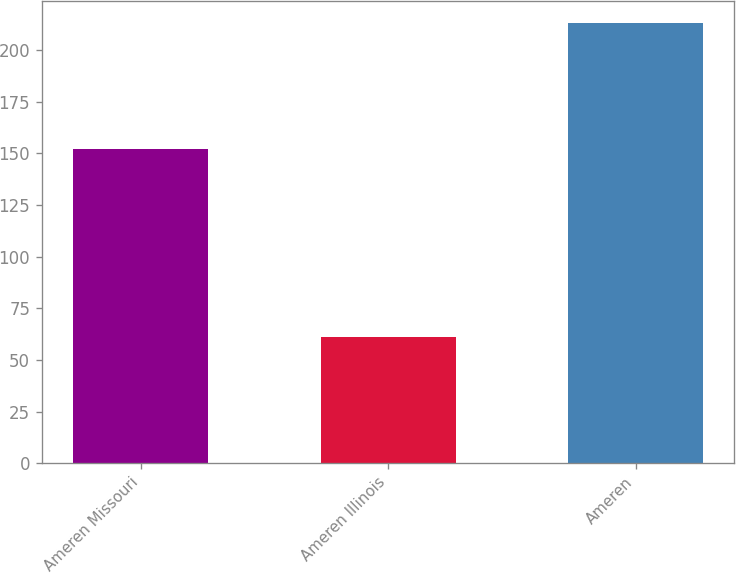Convert chart to OTSL. <chart><loc_0><loc_0><loc_500><loc_500><bar_chart><fcel>Ameren Missouri<fcel>Ameren Illinois<fcel>Ameren<nl><fcel>152<fcel>61<fcel>213<nl></chart> 